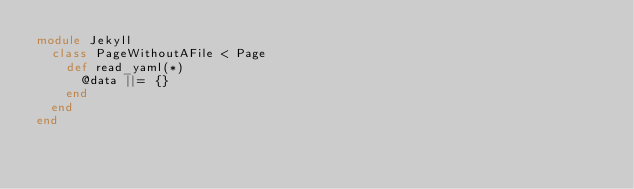<code> <loc_0><loc_0><loc_500><loc_500><_Ruby_>module Jekyll
  class PageWithoutAFile < Page
    def read_yaml(*)
      @data ||= {}
    end
  end
end
</code> 